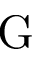Convert formula to latex. <formula><loc_0><loc_0><loc_500><loc_500>G</formula> 